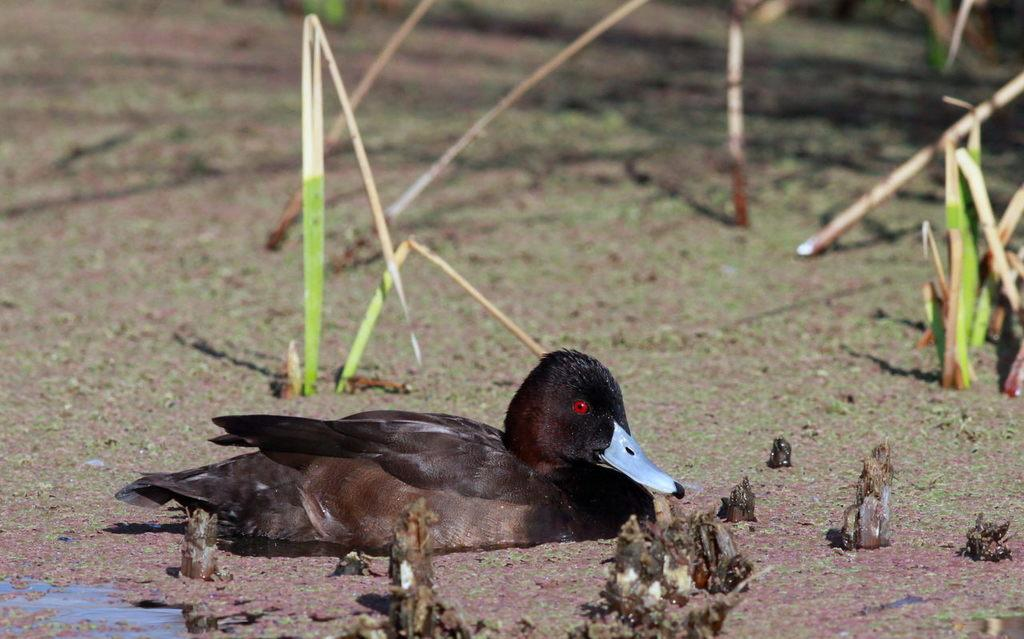What type of bird can be seen in the image? There is a black color bird in the image. What can be seen in the background of the image? There is grass in the background of the image. How would you describe the quality of the image? The image is slightly blurry in the background. Can you see any zippers on the bird in the image? There are no zippers present on the bird in the image, as it is a living creature and not a garment or object with zippers. 